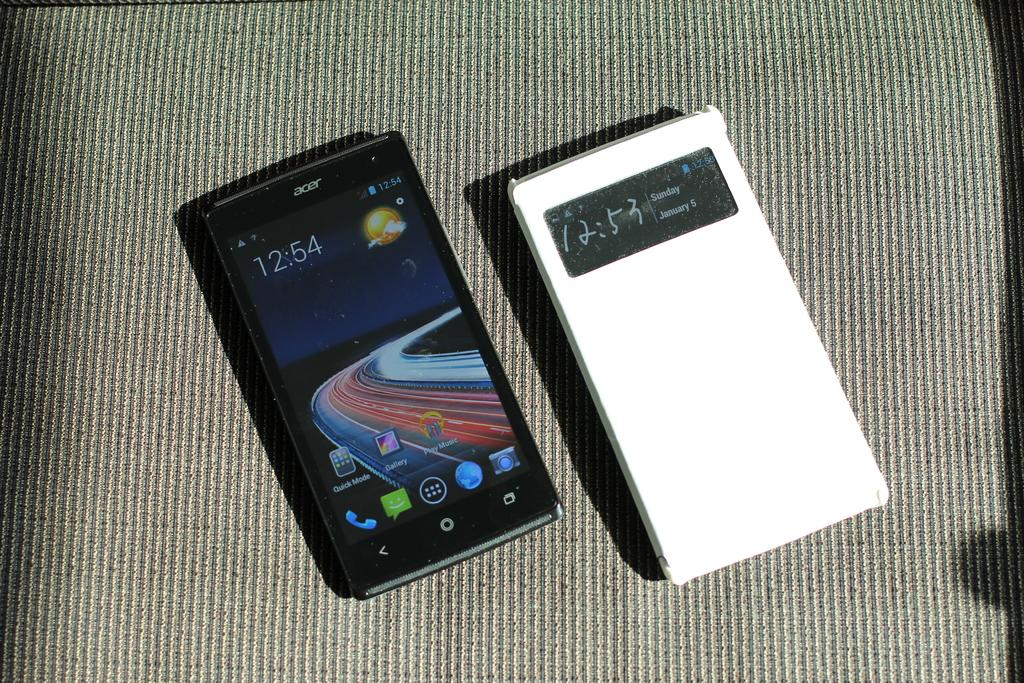<image>
Provide a brief description of the given image. a small black phone that reads 12:54 on it 